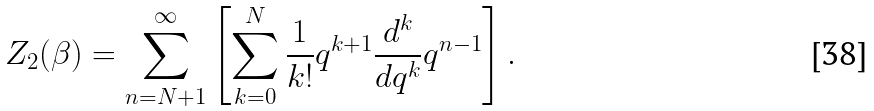<formula> <loc_0><loc_0><loc_500><loc_500>Z _ { 2 } ( \beta ) = \sum _ { n = N + 1 } ^ { \infty } \left [ \sum _ { k = 0 } ^ { N } \frac { 1 } { k ! } q ^ { k + 1 } \frac { d ^ { k } } { d q ^ { k } } q ^ { n - 1 } \right ] .</formula> 